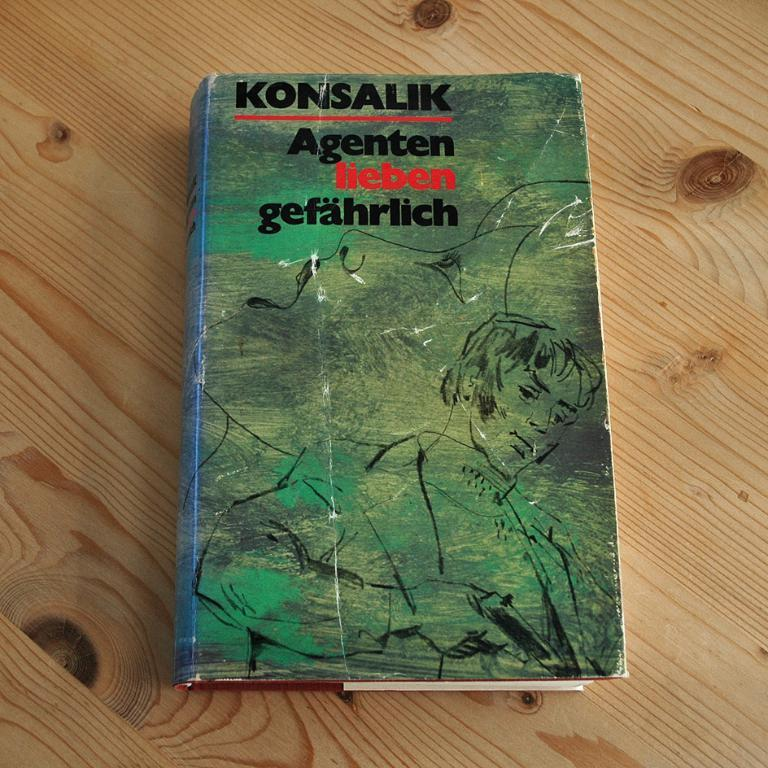<image>
Render a clear and concise summary of the photo. A worn book cover for a novel by Konsalik has a woman's face and a man sketched on it. 